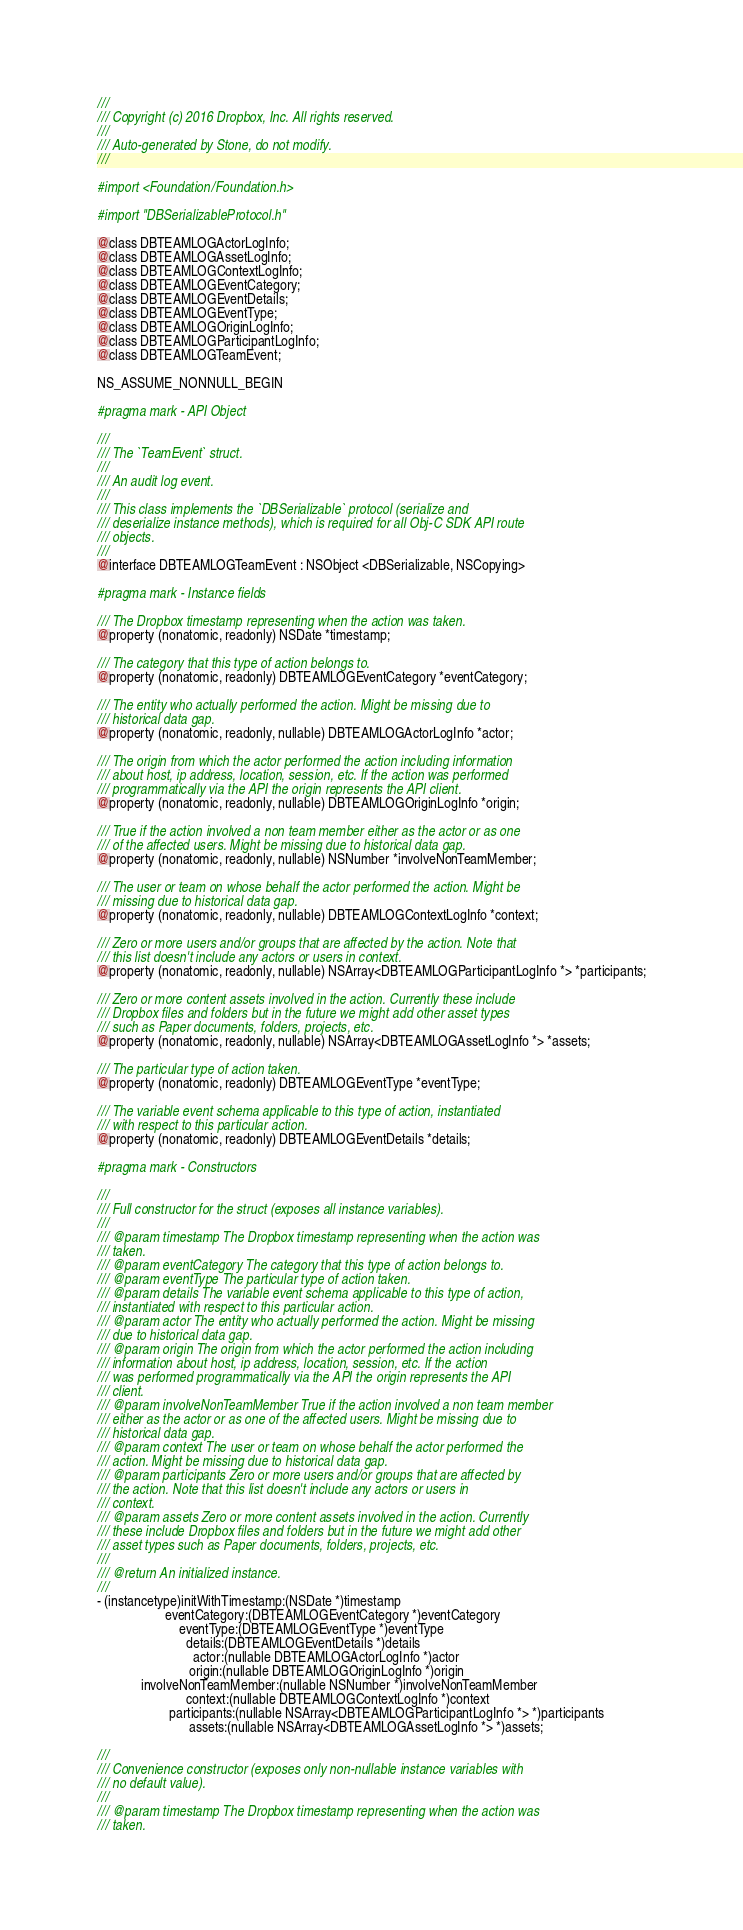<code> <loc_0><loc_0><loc_500><loc_500><_C_>///
/// Copyright (c) 2016 Dropbox, Inc. All rights reserved.
///
/// Auto-generated by Stone, do not modify.
///

#import <Foundation/Foundation.h>

#import "DBSerializableProtocol.h"

@class DBTEAMLOGActorLogInfo;
@class DBTEAMLOGAssetLogInfo;
@class DBTEAMLOGContextLogInfo;
@class DBTEAMLOGEventCategory;
@class DBTEAMLOGEventDetails;
@class DBTEAMLOGEventType;
@class DBTEAMLOGOriginLogInfo;
@class DBTEAMLOGParticipantLogInfo;
@class DBTEAMLOGTeamEvent;

NS_ASSUME_NONNULL_BEGIN

#pragma mark - API Object

///
/// The `TeamEvent` struct.
///
/// An audit log event.
///
/// This class implements the `DBSerializable` protocol (serialize and
/// deserialize instance methods), which is required for all Obj-C SDK API route
/// objects.
///
@interface DBTEAMLOGTeamEvent : NSObject <DBSerializable, NSCopying>

#pragma mark - Instance fields

/// The Dropbox timestamp representing when the action was taken.
@property (nonatomic, readonly) NSDate *timestamp;

/// The category that this type of action belongs to.
@property (nonatomic, readonly) DBTEAMLOGEventCategory *eventCategory;

/// The entity who actually performed the action. Might be missing due to
/// historical data gap.
@property (nonatomic, readonly, nullable) DBTEAMLOGActorLogInfo *actor;

/// The origin from which the actor performed the action including information
/// about host, ip address, location, session, etc. If the action was performed
/// programmatically via the API the origin represents the API client.
@property (nonatomic, readonly, nullable) DBTEAMLOGOriginLogInfo *origin;

/// True if the action involved a non team member either as the actor or as one
/// of the affected users. Might be missing due to historical data gap.
@property (nonatomic, readonly, nullable) NSNumber *involveNonTeamMember;

/// The user or team on whose behalf the actor performed the action. Might be
/// missing due to historical data gap.
@property (nonatomic, readonly, nullable) DBTEAMLOGContextLogInfo *context;

/// Zero or more users and/or groups that are affected by the action. Note that
/// this list doesn't include any actors or users in context.
@property (nonatomic, readonly, nullable) NSArray<DBTEAMLOGParticipantLogInfo *> *participants;

/// Zero or more content assets involved in the action. Currently these include
/// Dropbox files and folders but in the future we might add other asset types
/// such as Paper documents, folders, projects, etc.
@property (nonatomic, readonly, nullable) NSArray<DBTEAMLOGAssetLogInfo *> *assets;

/// The particular type of action taken.
@property (nonatomic, readonly) DBTEAMLOGEventType *eventType;

/// The variable event schema applicable to this type of action, instantiated
/// with respect to this particular action.
@property (nonatomic, readonly) DBTEAMLOGEventDetails *details;

#pragma mark - Constructors

///
/// Full constructor for the struct (exposes all instance variables).
///
/// @param timestamp The Dropbox timestamp representing when the action was
/// taken.
/// @param eventCategory The category that this type of action belongs to.
/// @param eventType The particular type of action taken.
/// @param details The variable event schema applicable to this type of action,
/// instantiated with respect to this particular action.
/// @param actor The entity who actually performed the action. Might be missing
/// due to historical data gap.
/// @param origin The origin from which the actor performed the action including
/// information about host, ip address, location, session, etc. If the action
/// was performed programmatically via the API the origin represents the API
/// client.
/// @param involveNonTeamMember True if the action involved a non team member
/// either as the actor or as one of the affected users. Might be missing due to
/// historical data gap.
/// @param context The user or team on whose behalf the actor performed the
/// action. Might be missing due to historical data gap.
/// @param participants Zero or more users and/or groups that are affected by
/// the action. Note that this list doesn't include any actors or users in
/// context.
/// @param assets Zero or more content assets involved in the action. Currently
/// these include Dropbox files and folders but in the future we might add other
/// asset types such as Paper documents, folders, projects, etc.
///
/// @return An initialized instance.
///
- (instancetype)initWithTimestamp:(NSDate *)timestamp
                    eventCategory:(DBTEAMLOGEventCategory *)eventCategory
                        eventType:(DBTEAMLOGEventType *)eventType
                          details:(DBTEAMLOGEventDetails *)details
                            actor:(nullable DBTEAMLOGActorLogInfo *)actor
                           origin:(nullable DBTEAMLOGOriginLogInfo *)origin
             involveNonTeamMember:(nullable NSNumber *)involveNonTeamMember
                          context:(nullable DBTEAMLOGContextLogInfo *)context
                     participants:(nullable NSArray<DBTEAMLOGParticipantLogInfo *> *)participants
                           assets:(nullable NSArray<DBTEAMLOGAssetLogInfo *> *)assets;

///
/// Convenience constructor (exposes only non-nullable instance variables with
/// no default value).
///
/// @param timestamp The Dropbox timestamp representing when the action was
/// taken.</code> 